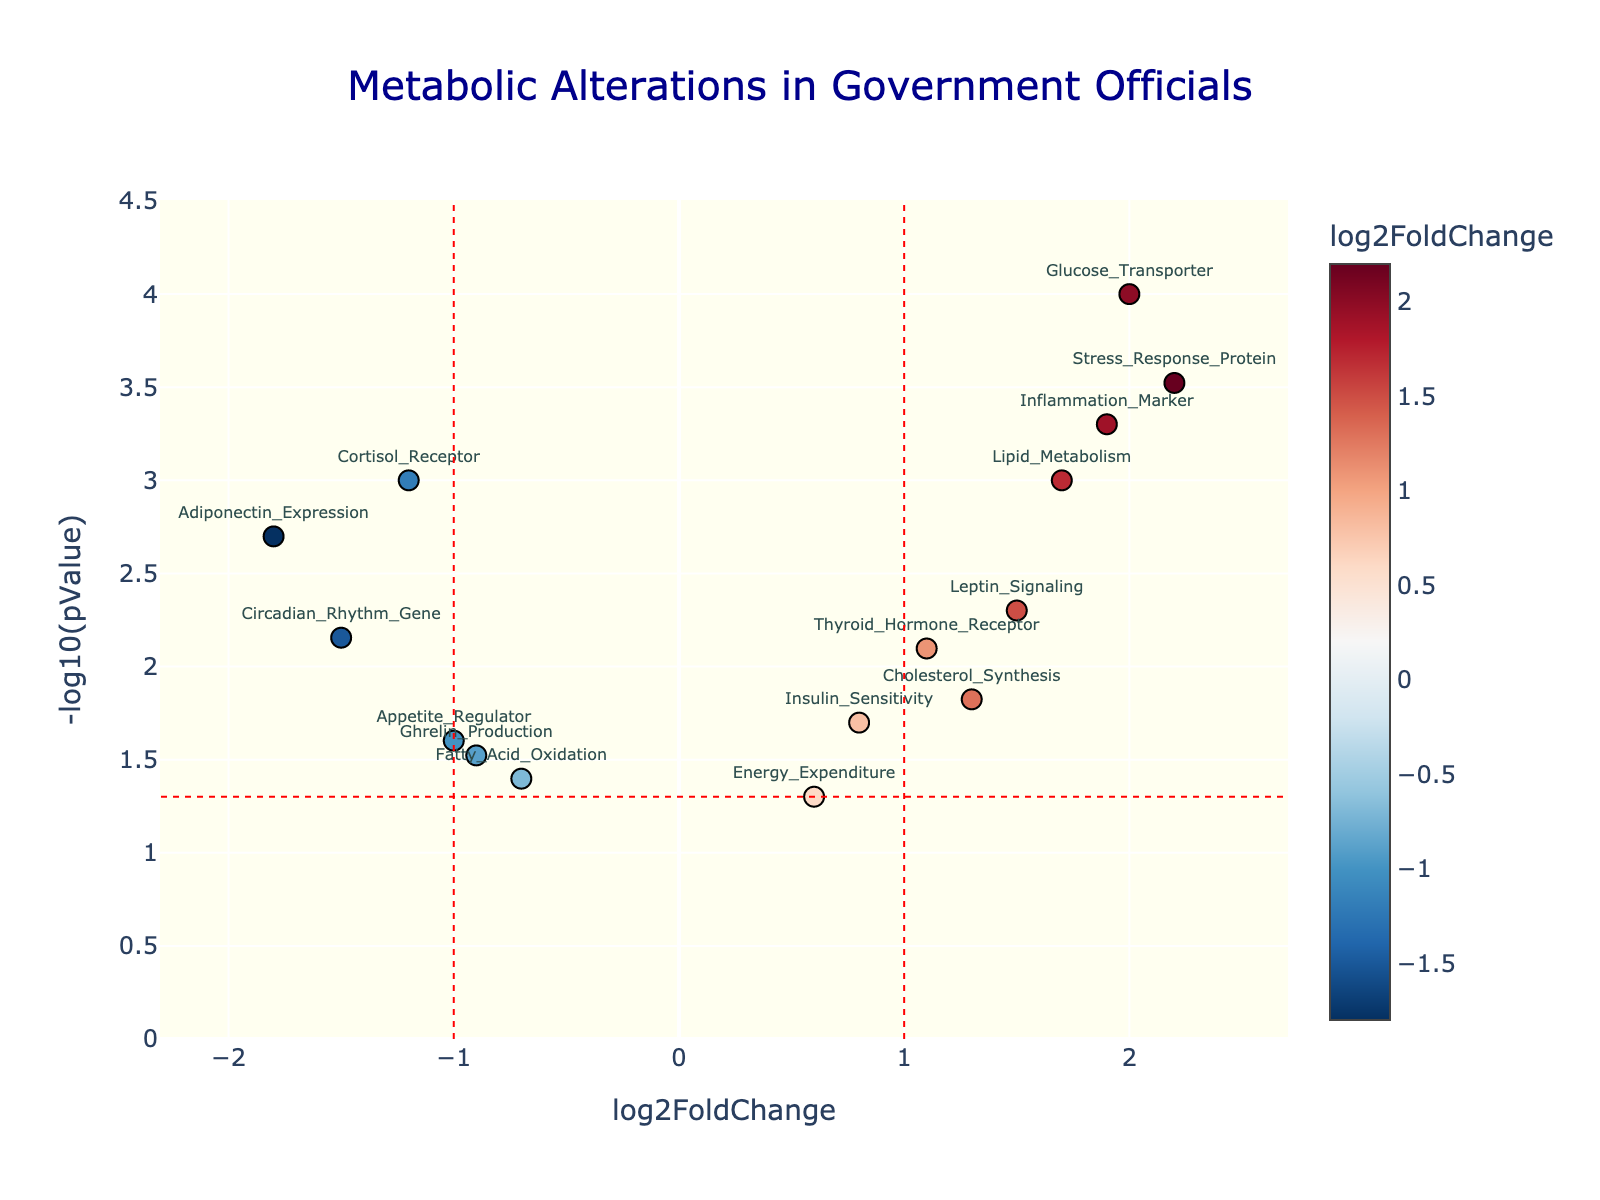How many data points are plotted in the figure? Count the number of data points present on the plot. Each data point corresponds to a gene. The total number of genes listed and plotted is 15.
Answer: 15 What's the title of the figure? The title is stated at the top of the plot. It reads "Metabolic Alterations in Government Officials."
Answer: Metabolic Alterations in Government Officials Which gene has the highest log2FoldChange? Identify the data point with the highest x-axis value. The gene "Stress_Response_Protein" has the highest log2FoldChange.
Answer: Stress_Response_Protein What is the log2FoldChange of "Adiponectin_Expression"? Locate the data point labeled "Adiponectin_Expression" and report its x-axis value. Its value is -1.8.
Answer: -1.8 How many genes have a -log10(pValue) greater than 2? Count the data points where the y-axis (-log10(pValue)) is greater than 2. There are 5 such data points: "Cortisol_Receptor", "Adiponectin_Expression", "Lipid_Metabolism", "Inflammation_Marker", and "Glucose_Transporter".
Answer: 5 Compare the -log10(pValue) of "Insulin_Sensitivity" and "Ghrelin_Production". Which one is higher? Locate the data points labeled "Insulin_Sensitivity" and "Ghrelin_Production". The y-axis value (-log10(pValue)) of "Insulin_Sensitivity" is 1.70, and "Ghrelin_Production" is 1.52. "Insulin_Sensitivity" is higher.
Answer: Insulin_Sensitivity Which gene appears closest to the vertical red line at log2FoldChange = 1? Identify the gene closest to the vertical red line at x = 1. The gene "Thyroid_Hormone_Receptor" appears closest.
Answer: Thyroid_Hormone_Receptor What is the significance threshold indicated by -log10(pValue)? The horizontal red line represents the significance threshold, which is set at p = 0.05, translating to -log10(pValue) of 1.3.
Answer: 1.3 What is the log2FoldChange value for the gene with the highest -log10(pValue)? Locate the data point with the highest y-axis value (-log10(pValue)). The gene "Glucose_Transporter" has the highest -log10(pValue) of 4.00 with a log2FoldChange of 2.0.
Answer: 2.0 How many genes have both a significant p-value (< 0.05) and an absolute log2FoldChange ≥ 1? Count the data points above the horizontal line (y > 1.3) and beyond the vertical lines (x ≤ -1 or x ≥ 1). These genes are "Cortisol_Receptor", "Adiponectin_Expression", "Lipid_Metabolism", "Circadian_Rhythm_Gene", "Inflammation_Marker", "Leptin_Signaling", "Cholesterol_Synthesis", "Thyroid_Hormone_Receptor", "Stress_Response_Protein", "Glucose_Transporter", summing to 11.
Answer: 11 